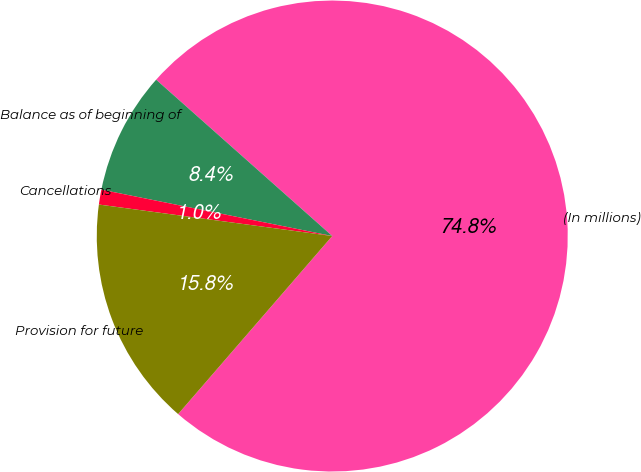Convert chart to OTSL. <chart><loc_0><loc_0><loc_500><loc_500><pie_chart><fcel>(In millions)<fcel>Balance as of beginning of<fcel>Cancellations<fcel>Provision for future<nl><fcel>74.8%<fcel>8.4%<fcel>1.02%<fcel>15.78%<nl></chart> 